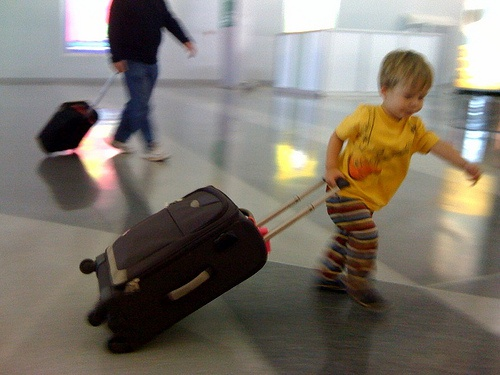Describe the objects in this image and their specific colors. I can see people in darkgray, olive, black, and maroon tones, suitcase in darkgray, black, and gray tones, people in darkgray, black, and gray tones, and suitcase in darkgray, black, maroon, and gray tones in this image. 